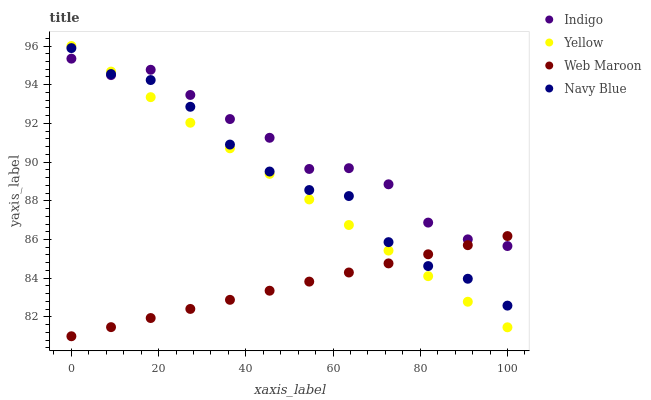Does Web Maroon have the minimum area under the curve?
Answer yes or no. Yes. Does Indigo have the maximum area under the curve?
Answer yes or no. Yes. Does Yellow have the minimum area under the curve?
Answer yes or no. No. Does Yellow have the maximum area under the curve?
Answer yes or no. No. Is Yellow the smoothest?
Answer yes or no. Yes. Is Indigo the roughest?
Answer yes or no. Yes. Is Indigo the smoothest?
Answer yes or no. No. Is Yellow the roughest?
Answer yes or no. No. Does Web Maroon have the lowest value?
Answer yes or no. Yes. Does Yellow have the lowest value?
Answer yes or no. No. Does Yellow have the highest value?
Answer yes or no. Yes. Does Indigo have the highest value?
Answer yes or no. No. Does Indigo intersect Web Maroon?
Answer yes or no. Yes. Is Indigo less than Web Maroon?
Answer yes or no. No. Is Indigo greater than Web Maroon?
Answer yes or no. No. 